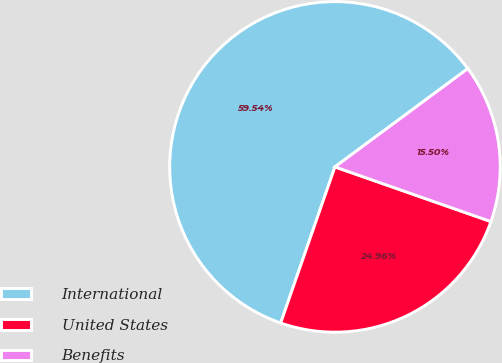Convert chart to OTSL. <chart><loc_0><loc_0><loc_500><loc_500><pie_chart><fcel>International<fcel>United States<fcel>Benefits<nl><fcel>59.54%<fcel>24.96%<fcel>15.5%<nl></chart> 